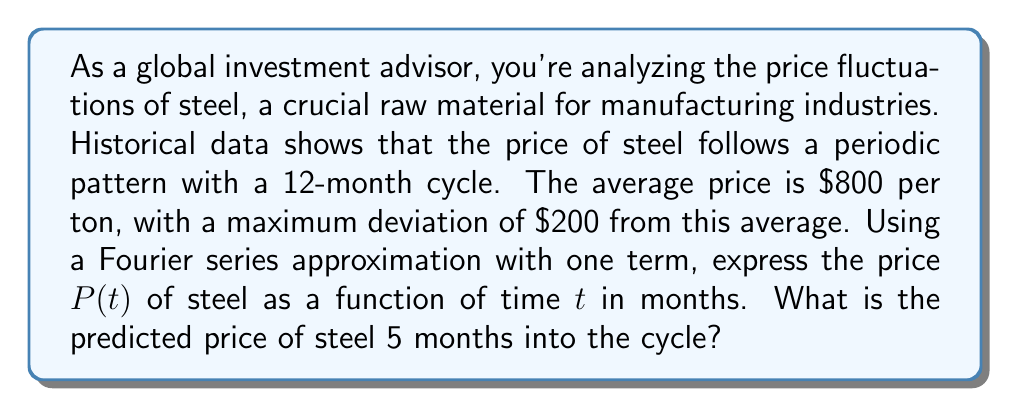Could you help me with this problem? To solve this problem, we'll follow these steps:

1) The general form of a Fourier series with one term is:

   $$P(t) = A_0 + A_1 \cos(\omega t) + B_1 \sin(\omega t)$$

   Where $A_0$ is the average value, $A_1$ and $B_1$ are coefficients, and $\omega$ is the angular frequency.

2) We're given:
   - Average price $A_0 = 800$
   - Maximum deviation = $200
   - Period = 12 months

3) The angular frequency $\omega$ is:

   $$\omega = \frac{2\pi}{T} = \frac{2\pi}{12} = \frac{\pi}{6}$$

4) Since we're only using one term and given the maximum deviation, we can simplify to:

   $$P(t) = 800 + 200 \cos(\frac{\pi}{6}t)$$

5) To find the price at 5 months:

   $$P(5) = 800 + 200 \cos(\frac{\pi}{6} \cdot 5)$$
   $$= 800 + 200 \cos(\frac{5\pi}{6})$$
   $$= 800 + 200 \cdot (-0.866)$$
   $$= 800 - 173.2$$
   $$= 626.8$$

Therefore, the predicted price of steel 5 months into the cycle is approximately $626.80 per ton.
Answer: $626.80 per ton 